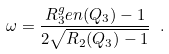Convert formula to latex. <formula><loc_0><loc_0><loc_500><loc_500>\omega = \frac { R _ { 3 } ^ { g } e n ( Q _ { 3 } ) - 1 } { 2 \sqrt { R _ { 2 } ( Q _ { 3 } ) - 1 } } \ .</formula> 